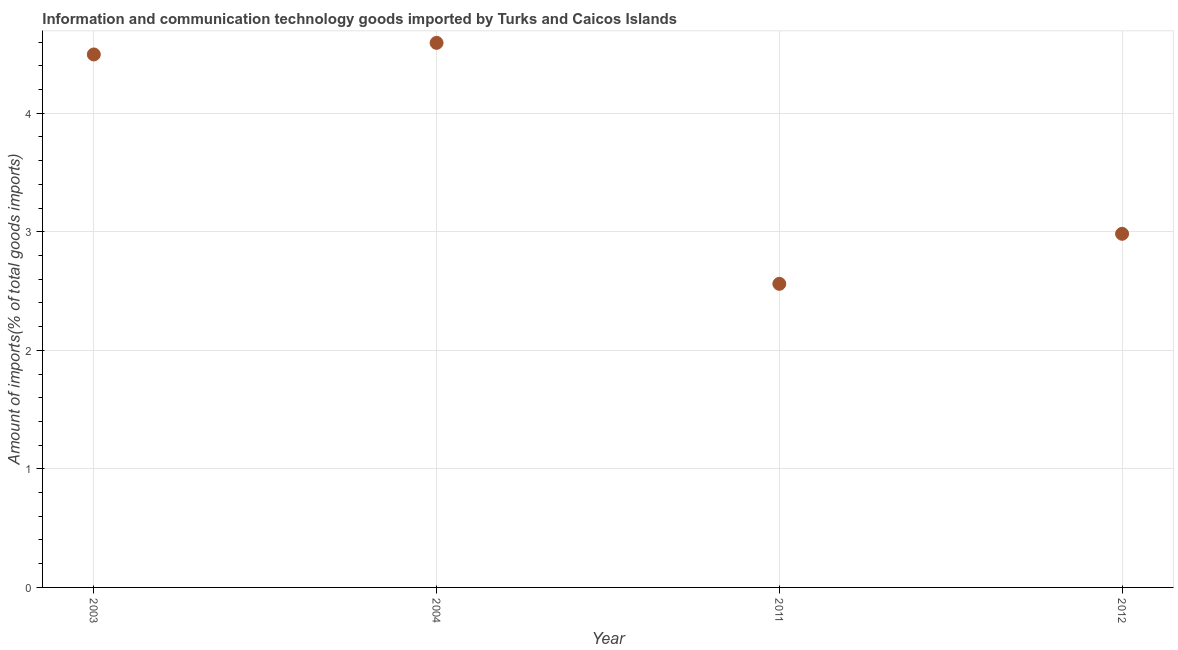What is the amount of ict goods imports in 2011?
Keep it short and to the point. 2.56. Across all years, what is the maximum amount of ict goods imports?
Give a very brief answer. 4.59. Across all years, what is the minimum amount of ict goods imports?
Provide a short and direct response. 2.56. In which year was the amount of ict goods imports minimum?
Your answer should be compact. 2011. What is the sum of the amount of ict goods imports?
Your answer should be compact. 14.63. What is the difference between the amount of ict goods imports in 2003 and 2012?
Provide a succinct answer. 1.51. What is the average amount of ict goods imports per year?
Your answer should be compact. 3.66. What is the median amount of ict goods imports?
Offer a terse response. 3.74. In how many years, is the amount of ict goods imports greater than 3.2 %?
Provide a succinct answer. 2. What is the ratio of the amount of ict goods imports in 2003 to that in 2004?
Provide a succinct answer. 0.98. What is the difference between the highest and the second highest amount of ict goods imports?
Your answer should be very brief. 0.1. What is the difference between the highest and the lowest amount of ict goods imports?
Your response must be concise. 2.03. In how many years, is the amount of ict goods imports greater than the average amount of ict goods imports taken over all years?
Your answer should be compact. 2. How many dotlines are there?
Give a very brief answer. 1. How many years are there in the graph?
Ensure brevity in your answer.  4. Are the values on the major ticks of Y-axis written in scientific E-notation?
Your response must be concise. No. Does the graph contain any zero values?
Provide a succinct answer. No. What is the title of the graph?
Make the answer very short. Information and communication technology goods imported by Turks and Caicos Islands. What is the label or title of the Y-axis?
Your response must be concise. Amount of imports(% of total goods imports). What is the Amount of imports(% of total goods imports) in 2003?
Offer a terse response. 4.5. What is the Amount of imports(% of total goods imports) in 2004?
Your response must be concise. 4.59. What is the Amount of imports(% of total goods imports) in 2011?
Provide a short and direct response. 2.56. What is the Amount of imports(% of total goods imports) in 2012?
Keep it short and to the point. 2.98. What is the difference between the Amount of imports(% of total goods imports) in 2003 and 2004?
Give a very brief answer. -0.1. What is the difference between the Amount of imports(% of total goods imports) in 2003 and 2011?
Offer a terse response. 1.93. What is the difference between the Amount of imports(% of total goods imports) in 2003 and 2012?
Offer a terse response. 1.51. What is the difference between the Amount of imports(% of total goods imports) in 2004 and 2011?
Your response must be concise. 2.03. What is the difference between the Amount of imports(% of total goods imports) in 2004 and 2012?
Provide a succinct answer. 1.61. What is the difference between the Amount of imports(% of total goods imports) in 2011 and 2012?
Your answer should be compact. -0.42. What is the ratio of the Amount of imports(% of total goods imports) in 2003 to that in 2011?
Offer a very short reply. 1.76. What is the ratio of the Amount of imports(% of total goods imports) in 2003 to that in 2012?
Your answer should be compact. 1.51. What is the ratio of the Amount of imports(% of total goods imports) in 2004 to that in 2011?
Give a very brief answer. 1.79. What is the ratio of the Amount of imports(% of total goods imports) in 2004 to that in 2012?
Offer a terse response. 1.54. What is the ratio of the Amount of imports(% of total goods imports) in 2011 to that in 2012?
Your answer should be compact. 0.86. 